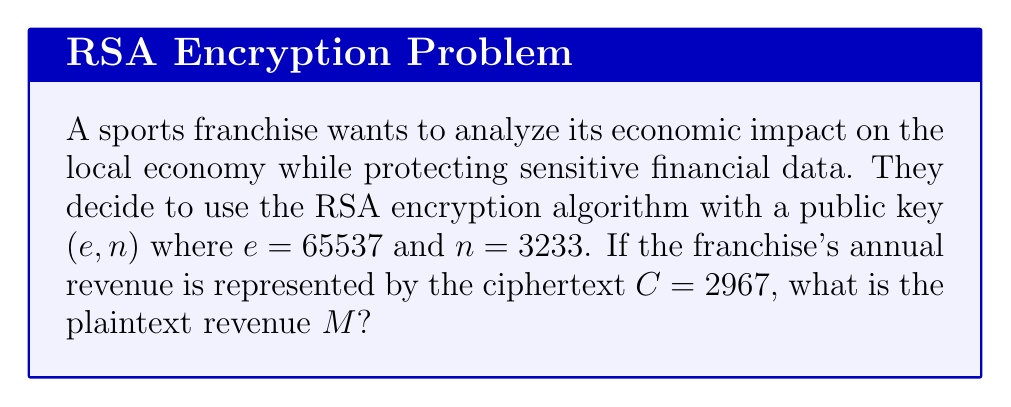Solve this math problem. To solve this problem, we need to decrypt the ciphertext using the RSA algorithm. The steps are as follows:

1) In RSA, the decryption formula is:
   $M \equiv C^d \pmod{n}$
   where $d$ is the private key exponent.

2) To find $d$, we need to factor $n$ and calculate $\phi(n)$:
   $n = 3233 = 61 \times 53$
   $\phi(n) = (61-1)(53-1) = 60 \times 52 = 3120$

3) Calculate $d$ using the modular multiplicative inverse:
   $d \equiv e^{-1} \pmod{\phi(n)}$
   $65537^{-1} \pmod{3120} = 2753$

4) Now we can decrypt:
   $M \equiv 2967^{2753} \pmod{3233}$

5) Using modular exponentiation techniques (like square-and-multiply algorithm):
   $M = 2500$

This decrypted value represents the annual revenue of the sports franchise.
Answer: $2500$ 